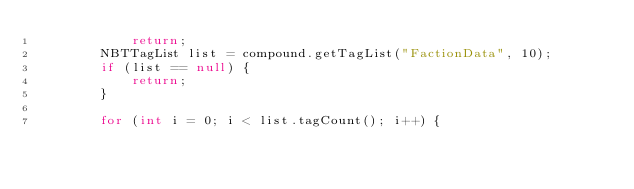Convert code to text. <code><loc_0><loc_0><loc_500><loc_500><_Java_>            return;
        NBTTagList list = compound.getTagList("FactionData", 10);
        if (list == null) {
            return;
        }

        for (int i = 0; i < list.tagCount(); i++) {</code> 